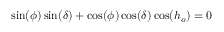<formula> <loc_0><loc_0><loc_500><loc_500>\sin ( \phi ) \sin ( \delta ) + \cos ( \phi ) \cos ( \delta ) \cos ( h _ { o } ) = 0</formula> 